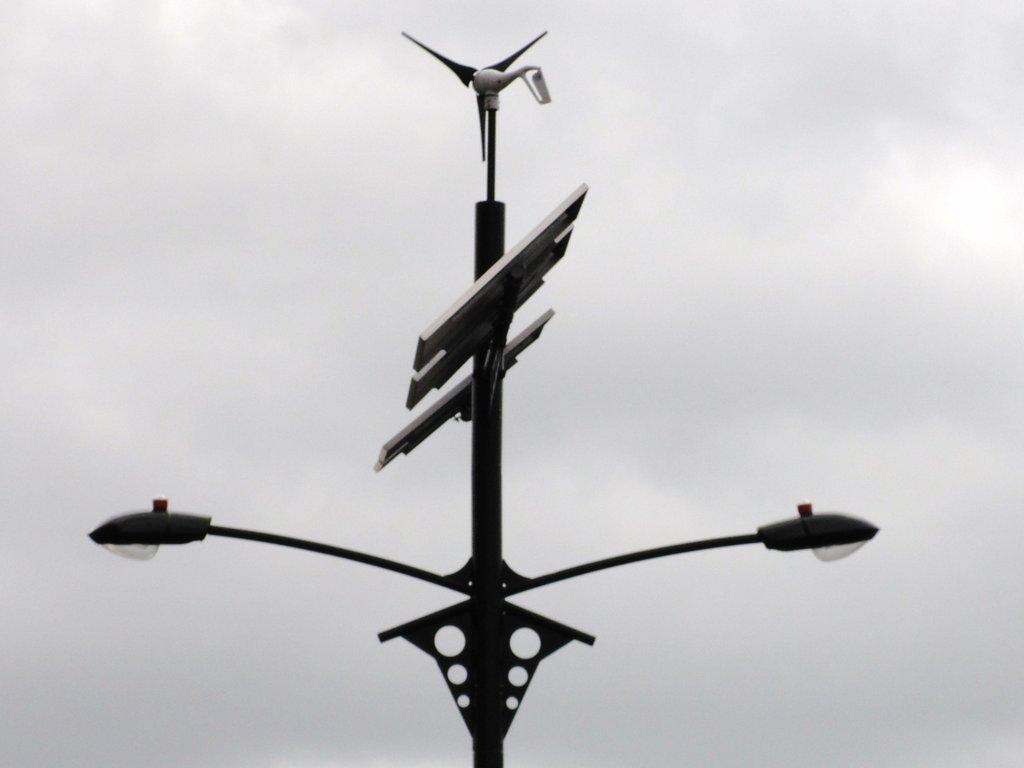Describe this image in one or two sentences. In this image I can see a pole to which two lights and some boards are attached. In the background, I can see the sky. 